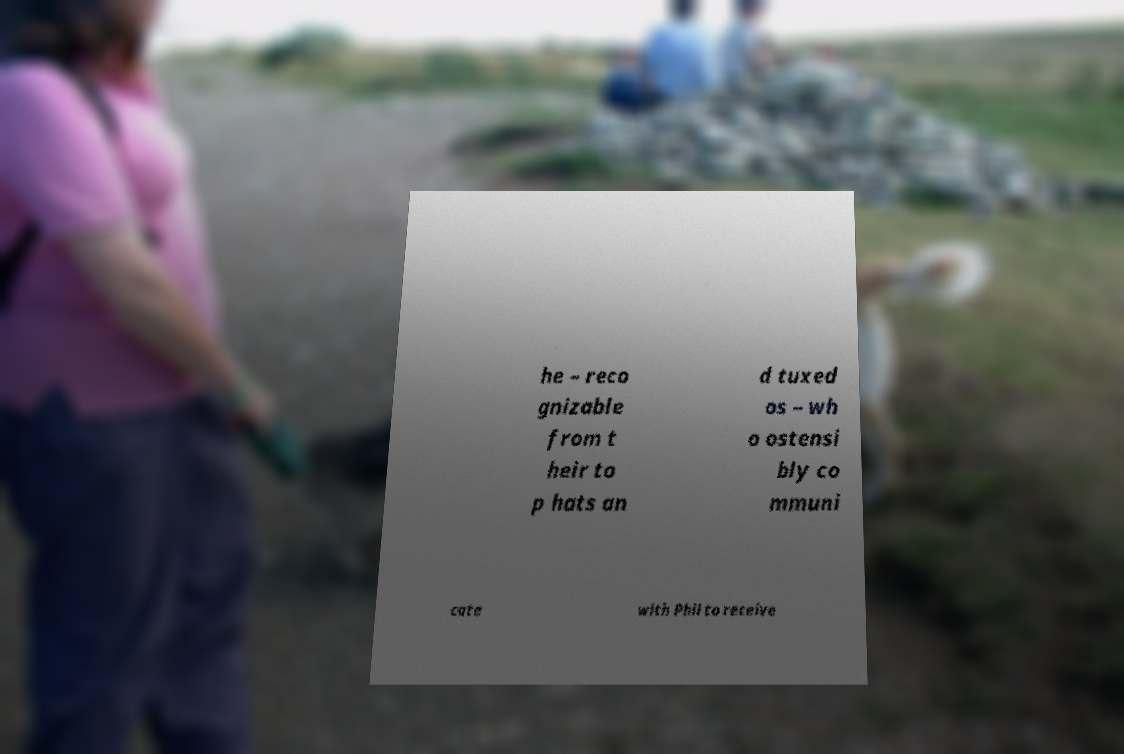Can you read and provide the text displayed in the image?This photo seems to have some interesting text. Can you extract and type it out for me? he – reco gnizable from t heir to p hats an d tuxed os – wh o ostensi bly co mmuni cate with Phil to receive 